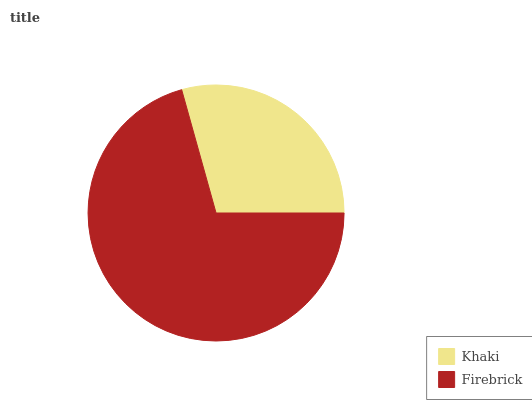Is Khaki the minimum?
Answer yes or no. Yes. Is Firebrick the maximum?
Answer yes or no. Yes. Is Firebrick the minimum?
Answer yes or no. No. Is Firebrick greater than Khaki?
Answer yes or no. Yes. Is Khaki less than Firebrick?
Answer yes or no. Yes. Is Khaki greater than Firebrick?
Answer yes or no. No. Is Firebrick less than Khaki?
Answer yes or no. No. Is Firebrick the high median?
Answer yes or no. Yes. Is Khaki the low median?
Answer yes or no. Yes. Is Khaki the high median?
Answer yes or no. No. Is Firebrick the low median?
Answer yes or no. No. 